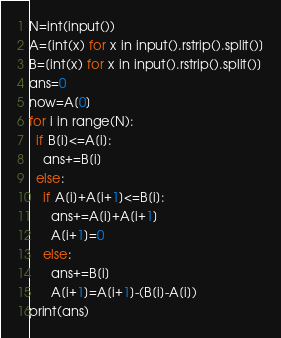<code> <loc_0><loc_0><loc_500><loc_500><_Python_>N=int(input())
A=[int(x) for x in input().rstrip().split()]
B=[int(x) for x in input().rstrip().split()]
ans=0
now=A[0]
for i in range(N):
  if B[i]<=A[i]:
    ans+=B[i]
  else:
    if A[i]+A[i+1]<=B[i]:
      ans+=A[i]+A[i+1]
      A[i+1]=0
    else:
      ans+=B[i]
      A[i+1]=A[i+1]-(B[i]-A[i])
print(ans)

</code> 